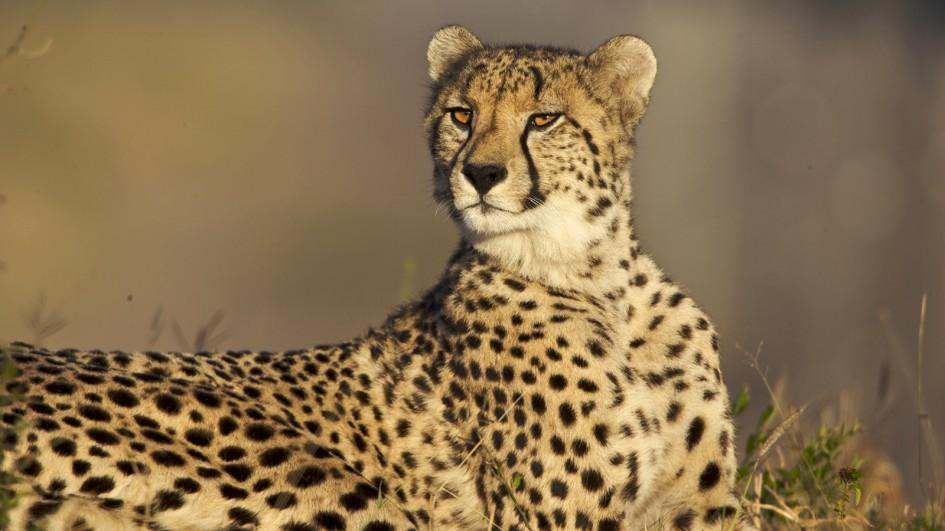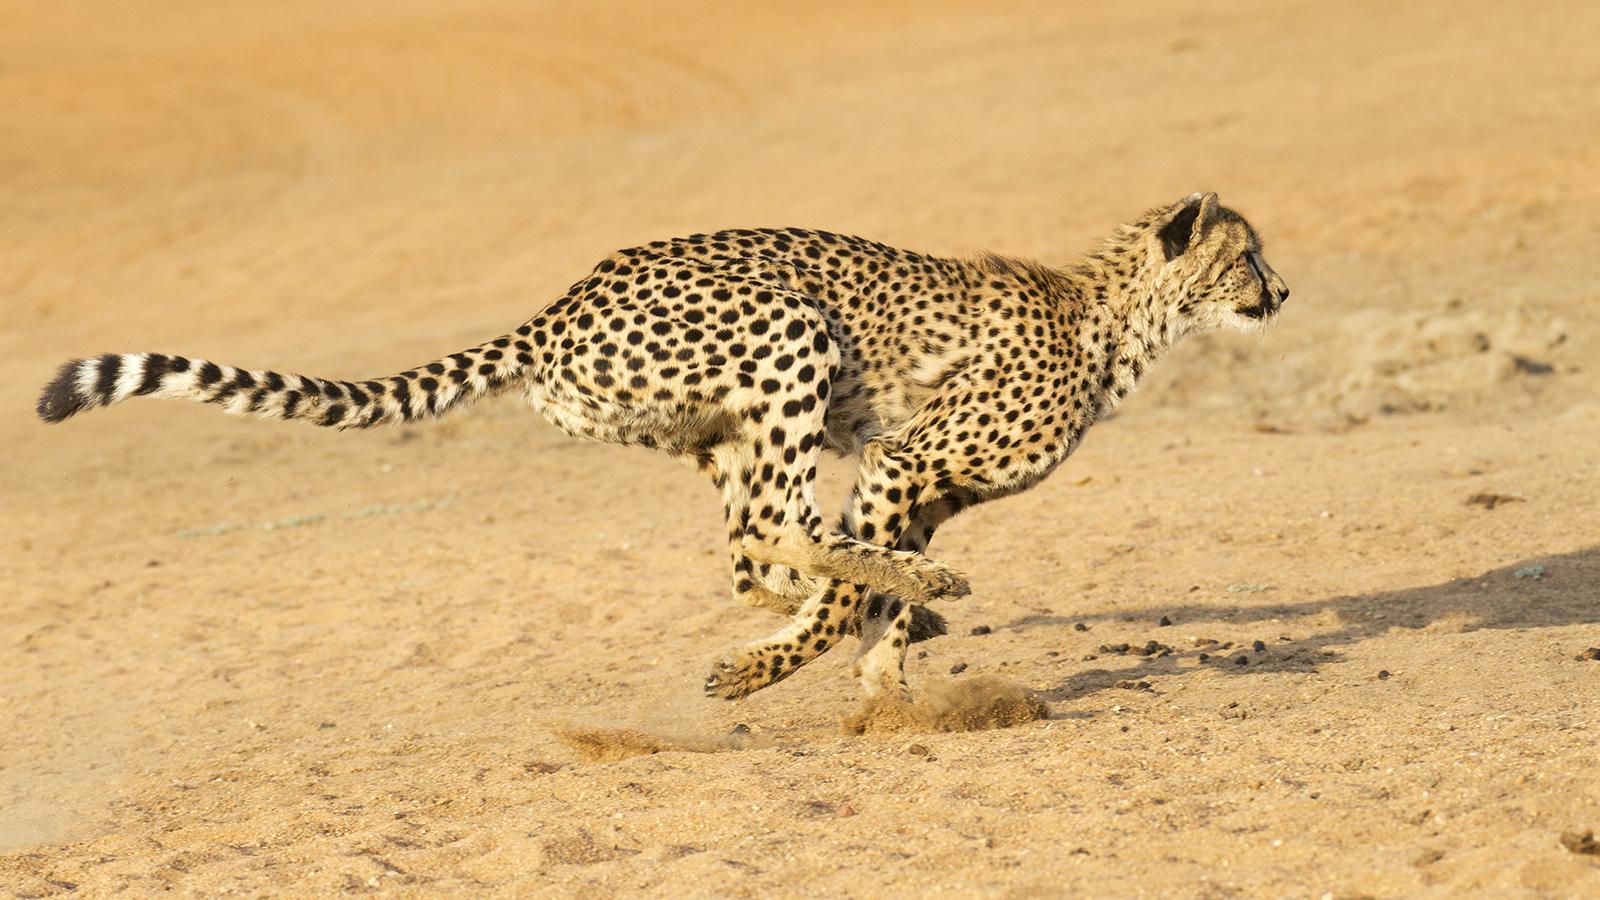The first image is the image on the left, the second image is the image on the right. Analyze the images presented: Is the assertion "A cheetah is in bounding pose, with its back legs forward, in front of its front legs." valid? Answer yes or no. Yes. The first image is the image on the left, the second image is the image on the right. Assess this claim about the two images: "A single leopard is lying down in the image on the left.". Correct or not? Answer yes or no. Yes. 